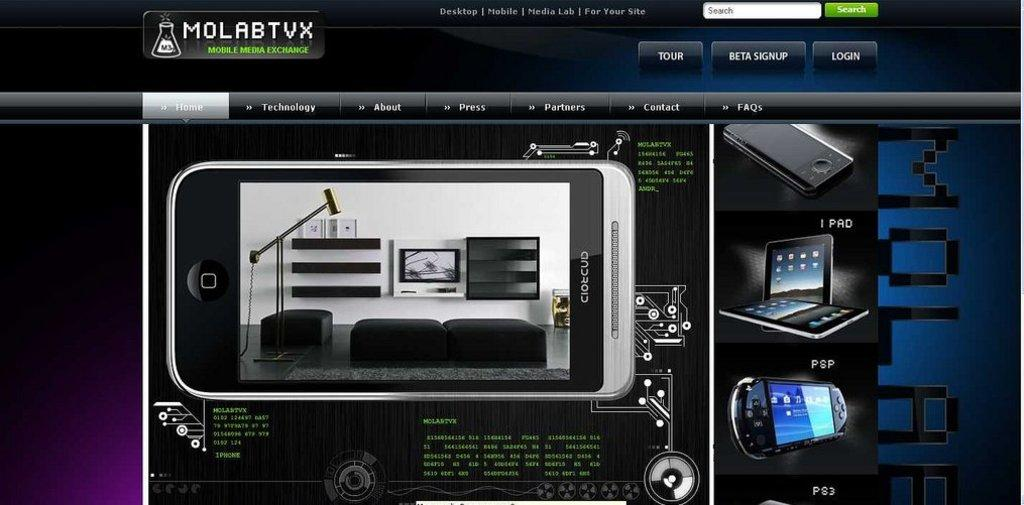<image>
Offer a succinct explanation of the picture presented. A website with a logo that says Molabtvx mobile media exchange. 